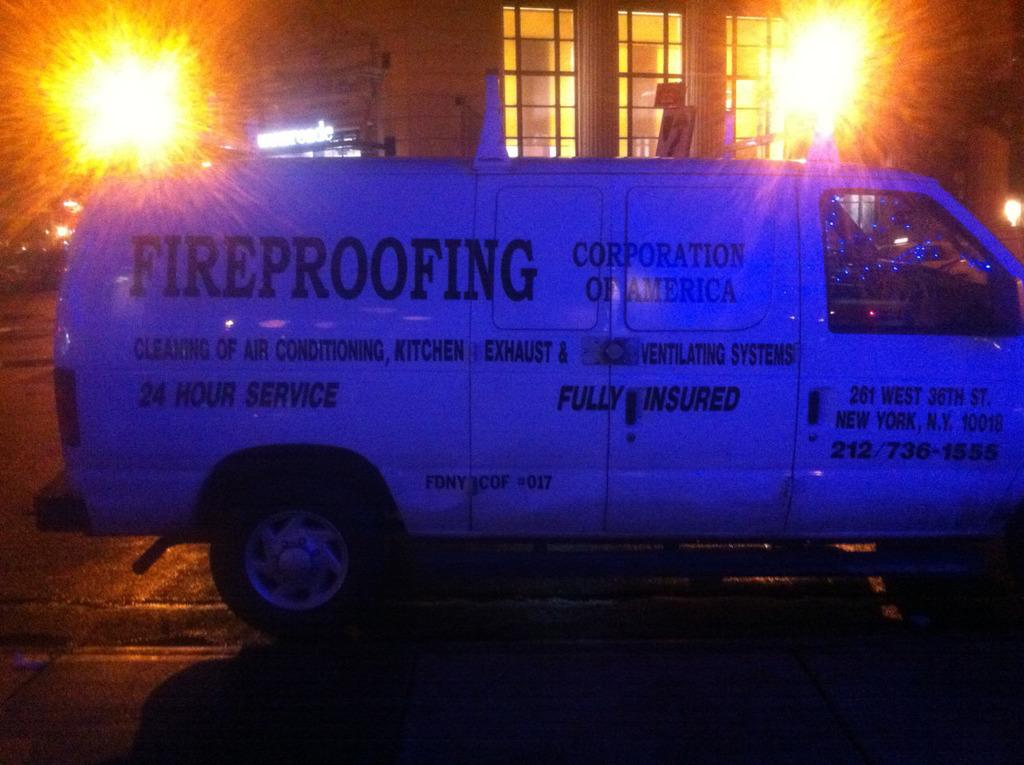Provide a one-sentence caption for the provided image. A van that says "FIREPROOFING" on the side is parked in front of a building at night. 